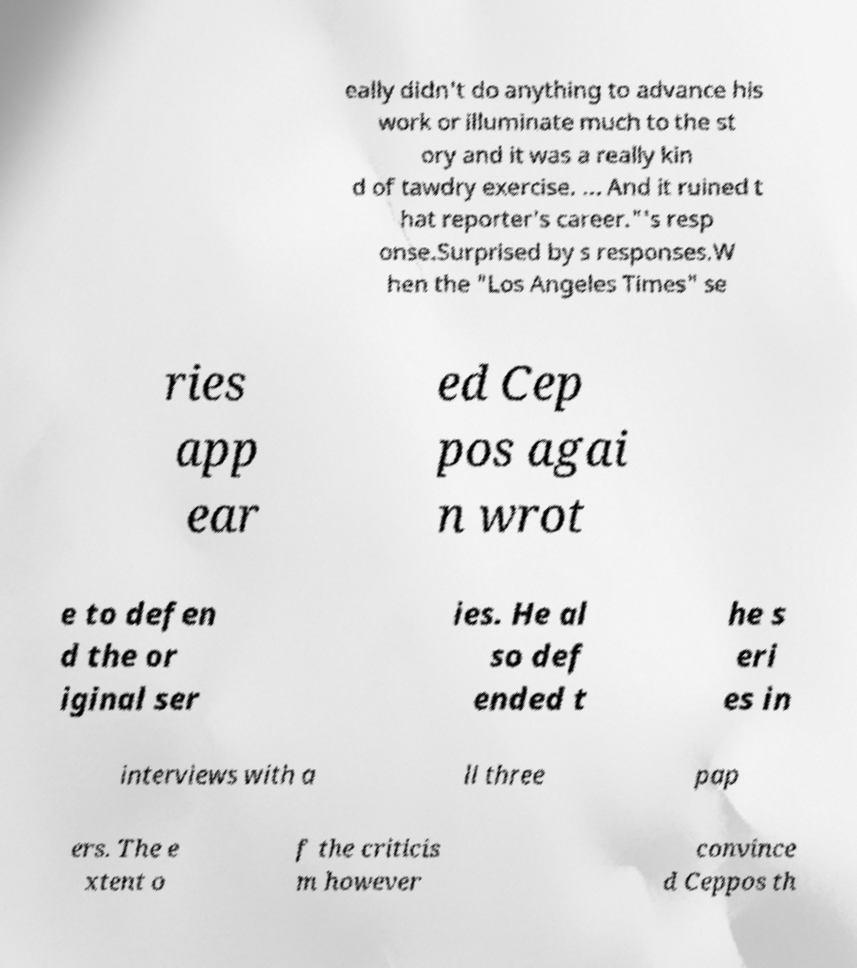There's text embedded in this image that I need extracted. Can you transcribe it verbatim? eally didn't do anything to advance his work or illuminate much to the st ory and it was a really kin d of tawdry exercise. ... And it ruined t hat reporter's career."'s resp onse.Surprised by s responses.W hen the "Los Angeles Times" se ries app ear ed Cep pos agai n wrot e to defen d the or iginal ser ies. He al so def ended t he s eri es in interviews with a ll three pap ers. The e xtent o f the criticis m however convince d Ceppos th 